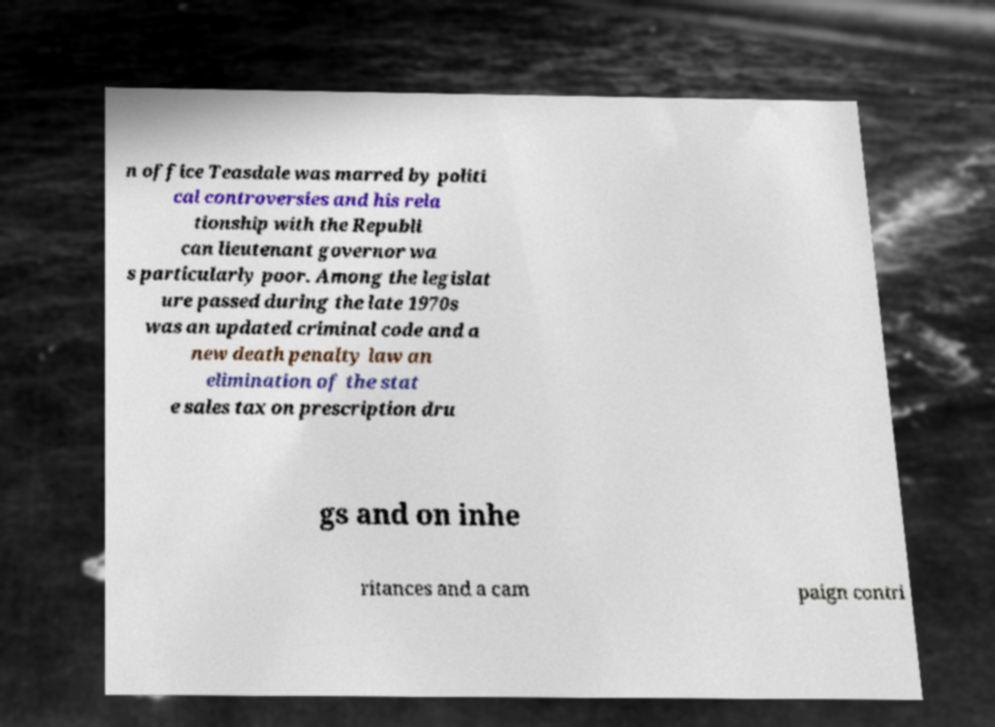For documentation purposes, I need the text within this image transcribed. Could you provide that? n office Teasdale was marred by politi cal controversies and his rela tionship with the Republi can lieutenant governor wa s particularly poor. Among the legislat ure passed during the late 1970s was an updated criminal code and a new death penalty law an elimination of the stat e sales tax on prescription dru gs and on inhe ritances and a cam paign contri 